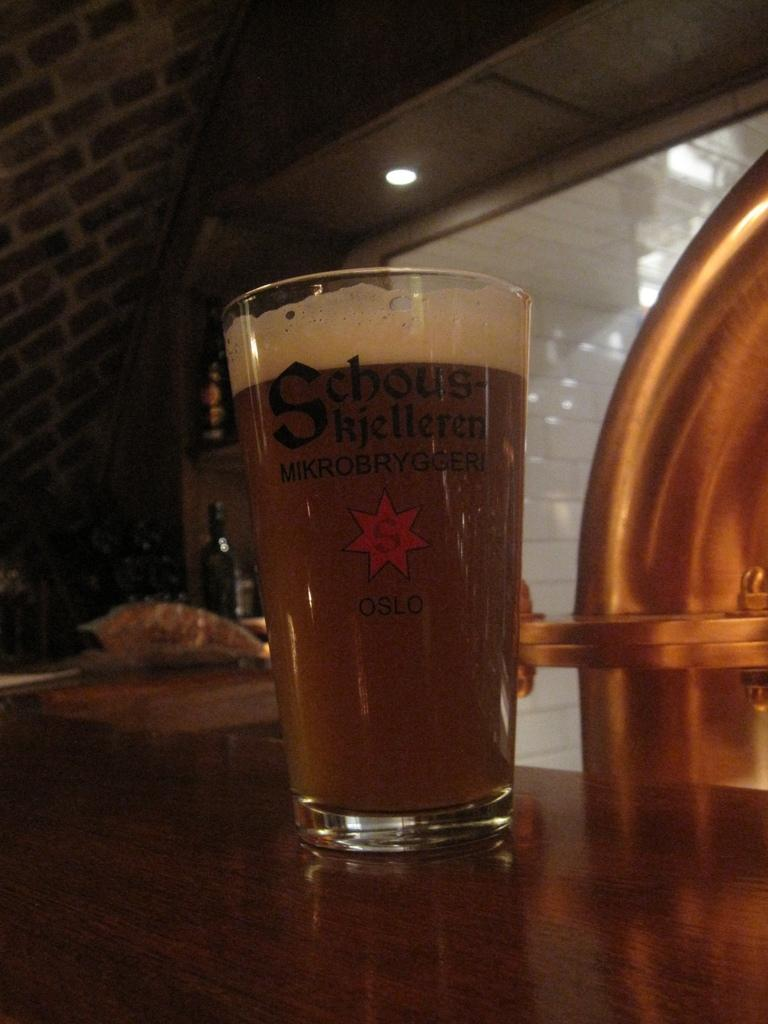<image>
Present a compact description of the photo's key features. The glass cup on the counter has the city Oslo on it 